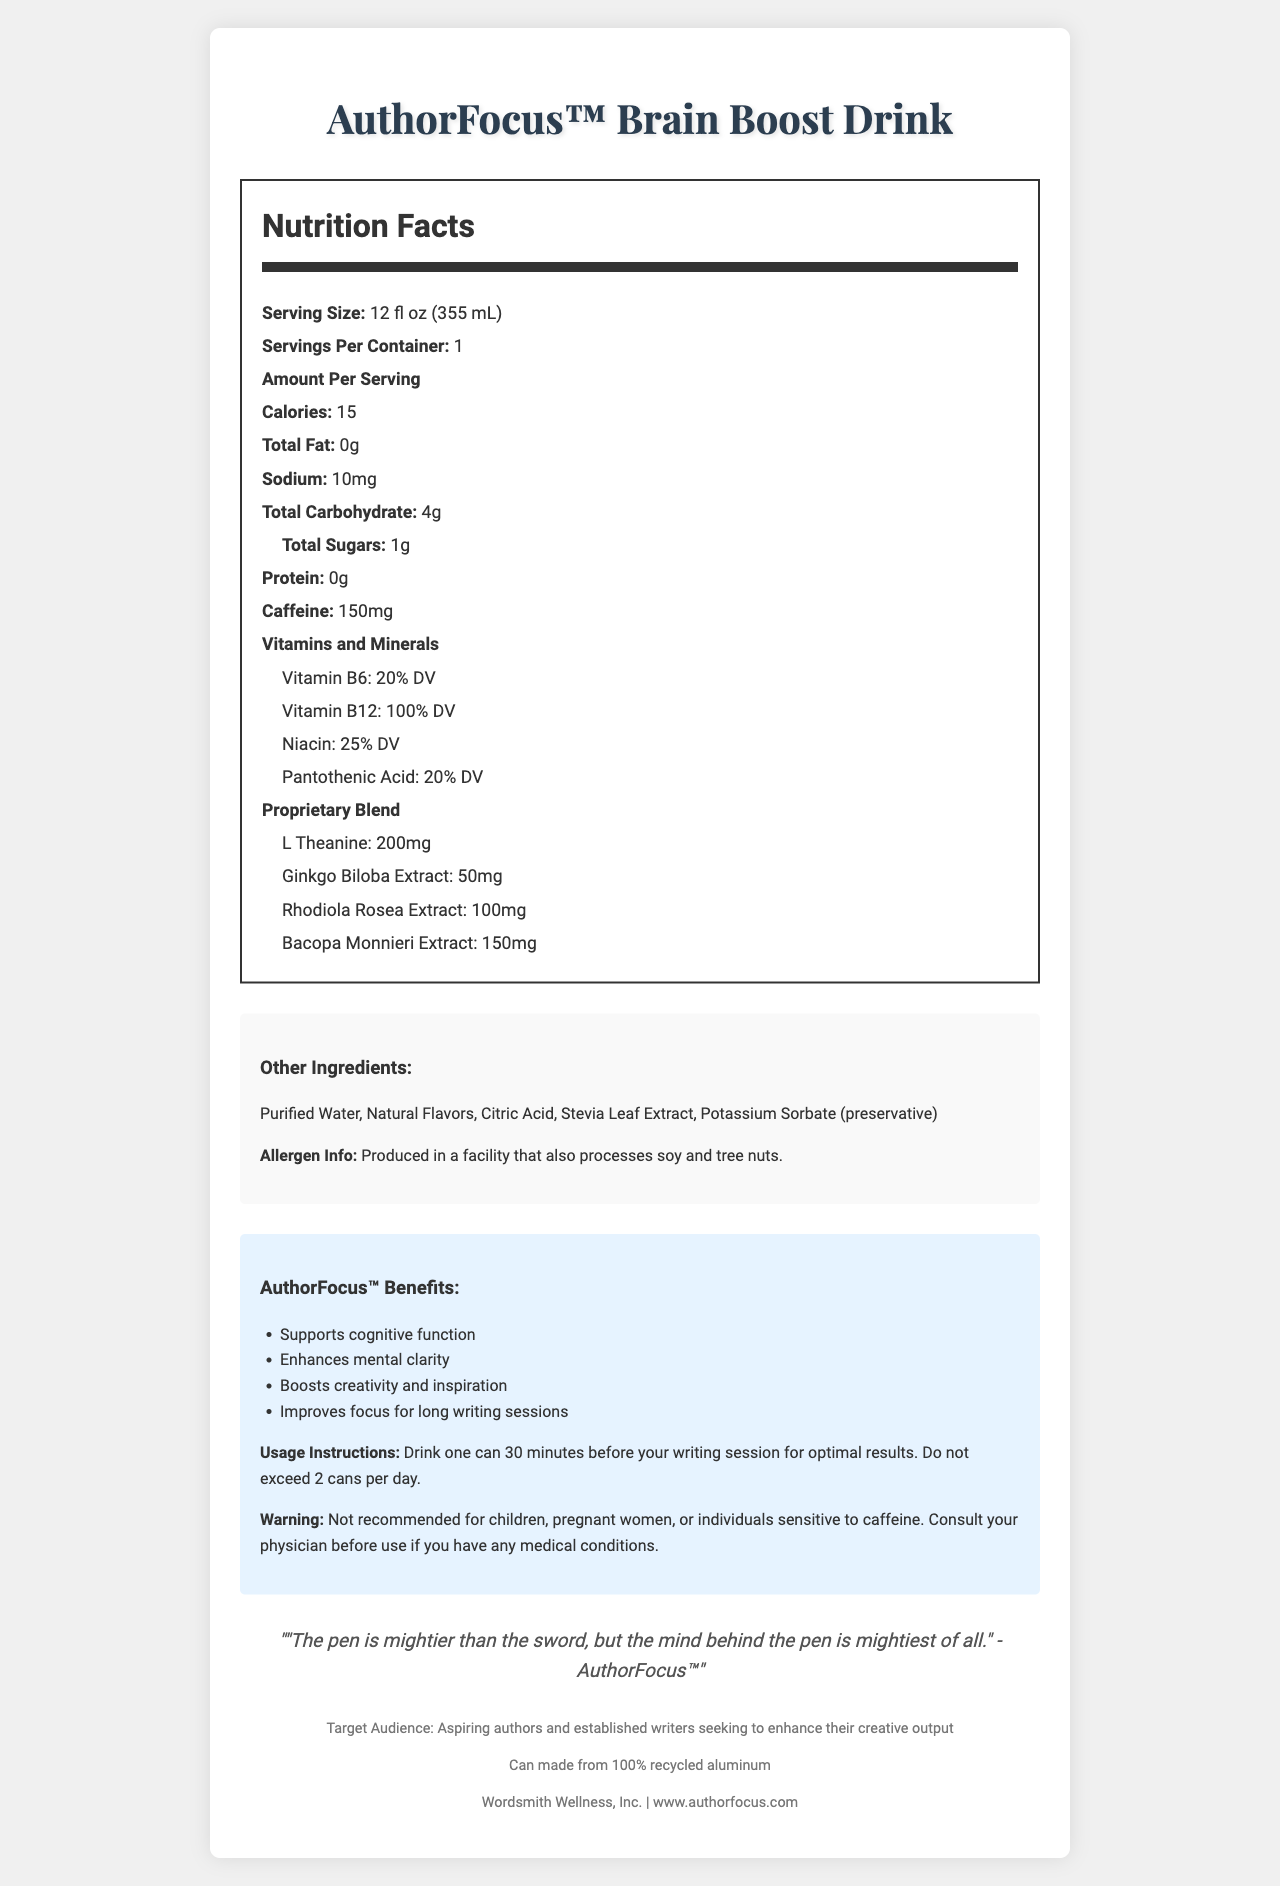what is the serving size? The document lists the serving size as 12 fl oz (355 mL).
Answer: 12 fl oz (355 mL) how many calories per serving are in the AuthorFocus™ Brain Boost Drink? The nutrition label indicates there are 15 calories per serving.
Answer: 15 what is the total amount of sugars in a serving of this beverage? The nutrition label states that the total sugars per serving are 1g.
Answer: 1g which ingredient in the proprietary blend has the highest amount? The proprietary blend section lists L-Theanine as 200mg, which is the highest amount among the ingredients listed.
Answer: L-Theanine what are the recommended usage instructions for AuthorFocus™? The usage instructions clearly state to drink one can 30 minutes before a writing session and not to exceed 2 cans per day.
Answer: Drink one can 30 minutes before your writing session for optimal results. Do not exceed 2 cans per day. what vitamins and minerals are included in the AuthorFocus™ Brain Boost Drink? A. Vitamin B6 B. Vitamin B12 C. Niacin D. All of the above Under the "Vitamins and Minerals" section, Vitamin B6, Vitamin B12, and Niacin are all listed.
Answer: D. All of the above what company produces the AuthorFocus™ Brain Boost Drink? A. Literary Labs B. Wordsmith Wellness, Inc. C. Author Energy, LLC The document states that Wordsmith Wellness, Inc. is the parent company.
Answer: B. Wordsmith Wellness, Inc. is the packaging of AuthorFocus™ eco-friendly? The document mentions that the can is made from 100% recycled aluminum, indicating the packaging is eco-friendly.
Answer: Yes summarize the key information about the AuthorFocus™ Brain Boost Drink. The document provides detailed information on the nutritional content, ingredients, benefits, usage instructions, target audience, and packaging of the AuthorFocus™ Brain Boost Drink.
Answer: The AuthorFocus™ Brain Boost Drink is a low-sugar, caffeine-infused beverage designed to enhance focus and concentration. It is 12 fl oz per serving with 15 calories, 1g of sugar, and 150mg of caffeine. The drink includes a proprietary blend with ingredients like L-Theanine and Bacopa Monnieri extract. It contains essential vitamins and minerals such as Vitamin B6 and B12. Usage instructions recommend drinking one can 30 minutes before writing, and not exceeding 2 cans per day. The drink is targeted at aspiring and established authors and is packaged in eco-friendly materials. is this drink recommended for children? The warning section explicitly states that the drink is not recommended for children, along with pregnant women and individuals sensitive to caffeine.
Answer: No what is the concentration of niacin in terms of daily value? The vitamins and minerals section lists niacin as providing 25% of the daily value (DV).
Answer: 25% DV who is the target audience for AuthorFocus™ Brain Boost Drink? The footer section states that the target audience includes aspiring authors and established writers seeking to enhance their creative output.
Answer: Aspiring authors and established writers what is the primary claim made by AuthorFocus™ Brain Boost Drink? The marketing claims section lists "Supports cognitive function" as one of the primary claims made by the drink.
Answer: Supports cognitive function does the document provide information about the production date of the drink? The document does not provide any information related to the production date of the drink.
Answer: Not enough information 